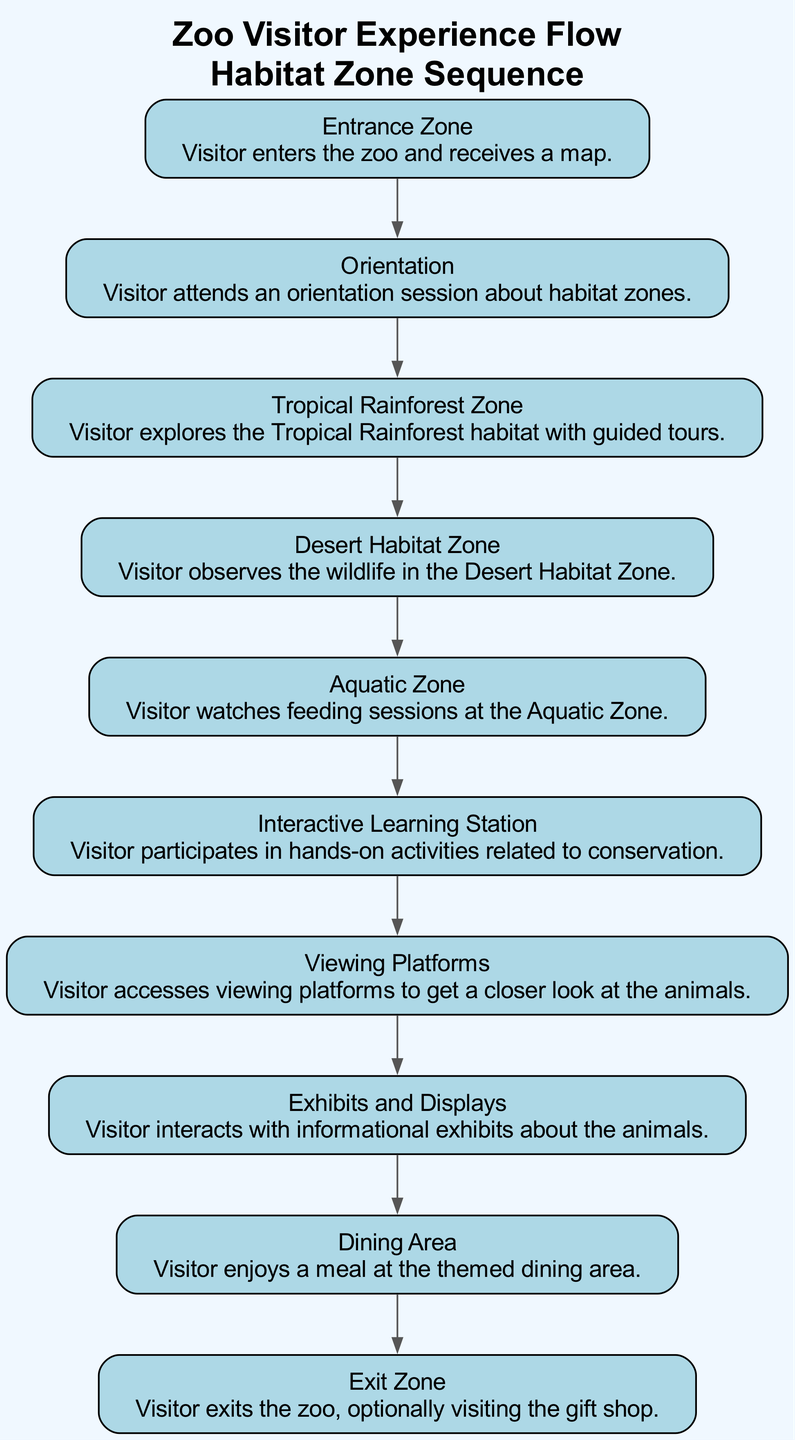What is the first step in the visitor experience flow? The first step listed in the diagram is "Entrance Zone" where visitors enter the zoo.
Answer: Entrance Zone How many habitat zones are indicated in the diagram? By counting the steps, there are four habitat zones mentioned: Tropical Rainforest Zone, Desert Habitat Zone, Aquatic Zone, and Interactive Learning Station.
Answer: Four What action is associated with the Aquatic Zone? The action tied to the Aquatic Zone is watching feeding sessions, as specified in the diagram.
Answer: Watching feeding sessions Which zone follows the Tropical Rainforest Zone? The step that comes directly after the Tropical Rainforest Zone is the Desert Habitat Zone.
Answer: Desert Habitat Zone What is the last action a visitor can take before exiting the zoo? The last action listed is visiting the gift shop upon exiting the zoo.
Answer: Visiting the gift shop What is the primary purpose of the Interactive Learning Station? The primary purpose is for visitors to participate in hands-on activities related to conservation.
Answer: Hands-on activities related to conservation How does the visitor flow transition from the Dining Area? After the Dining Area, the sequence shows that visitors transition to the Exit Zone, indicating a linear flow that leads to leaving the zoo.
Answer: Exit Zone Which step comes immediately before the Viewing Platforms? The step that comes immediately before Viewing Platforms is the Interactive Learning Station.
Answer: Interactive Learning Station What information does the "Exhibits and Displays" section provide to visitors? It provides visitors with the ability to interact with informational exhibits about the animals, enhancing their learning experience.
Answer: Informational exhibits about the animals 